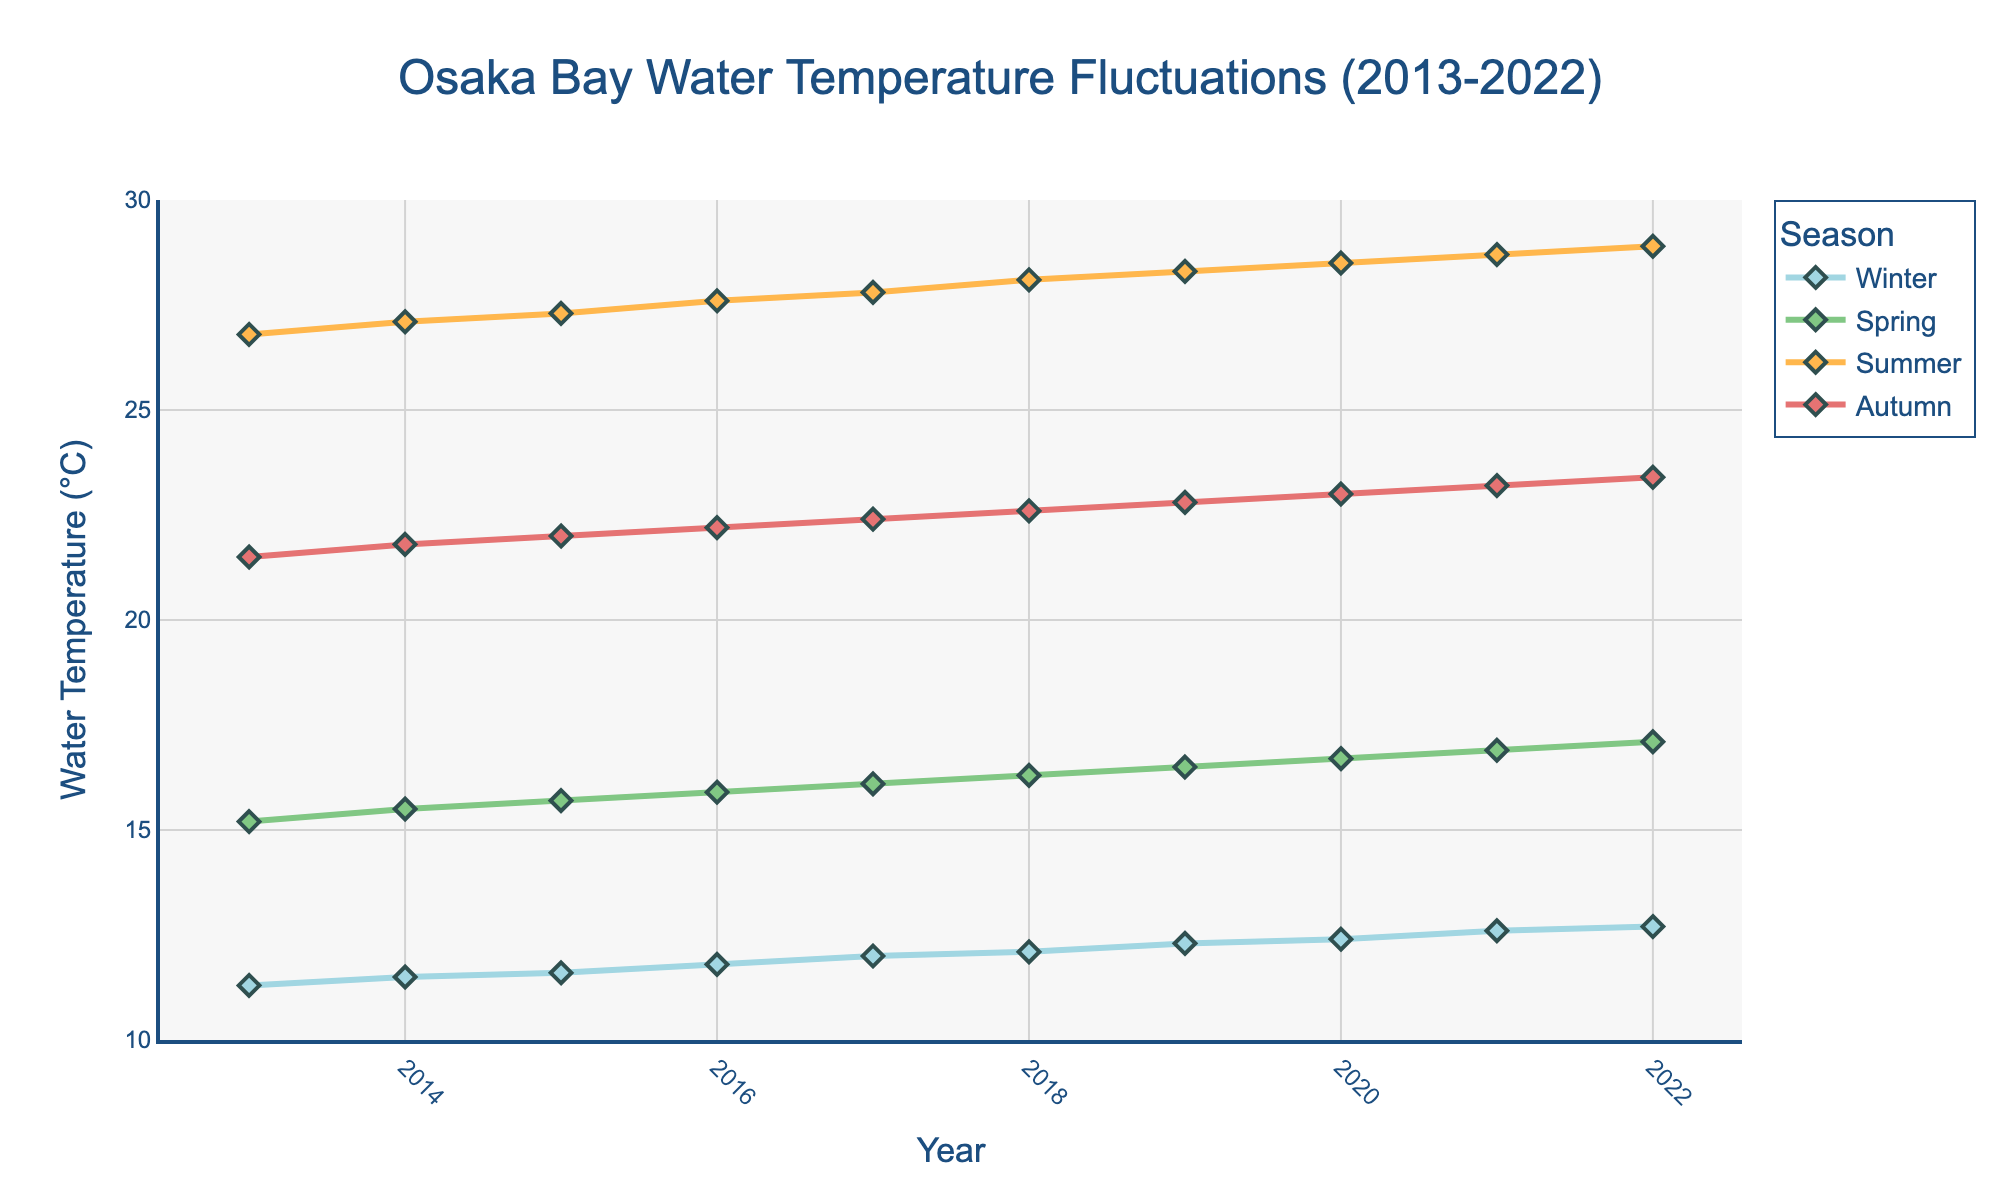What is the general trend of the water temperature in Osaka Bay across the last decade? The water temperature in Osaka Bay shows an increasing trend across all seasons over the last decade. Observing the line chart, each seasonal line trends upwards, indicating a general rise in water temperature from 2013 to 2022.
Answer: Increasing trend Which season experienced the highest change in water temperature between 2013 and 2022? Look at the start and end points of each season's line. Calculate the difference for each: Winter (12.7 - 11.3 = 1.4°C), Spring (17.1 - 15.2 = 1.9°C), Summer (28.9 - 26.8 = 2.1°C), Autumn (23.4 - 21.5 = 1.9°C). Summer experienced the highest change.
Answer: Summer Which season consistently shows the highest water temperatures every year? By observing the line chart, the top line (representing the highest temperature) is always the one for Summer. Each year, the peak temperature corresponds to Summer.
Answer: Summer What is the lowest water temperature recorded in 2022, and which season does it correspond to? Look at the data points for the year 2022. The lowest temperature for that year is 12.7°C, which corresponds to the Winter season.
Answer: 12.7°C, Winter How much did the water temperature in Summer increase from 2013 to 2019? Subtract the water temperature in Summer 2013 from that in Summer 2019 (28.3°C - 26.8°C). The increase is 1.5°C.
Answer: 1.5°C During which year does Spring water temperature reach 16.7°C? Find the data point on the Spring line chart where the temperature value is 16.7°C. This occurs in the year 2020.
Answer: 2020 How did the Winter temperatures change from 2013 to 2022? Calculate the difference between Winter temperatures in 2013 and 2022 (12.7°C - 11.3°C). The change is 1.4°C.
Answer: 1.4°C 